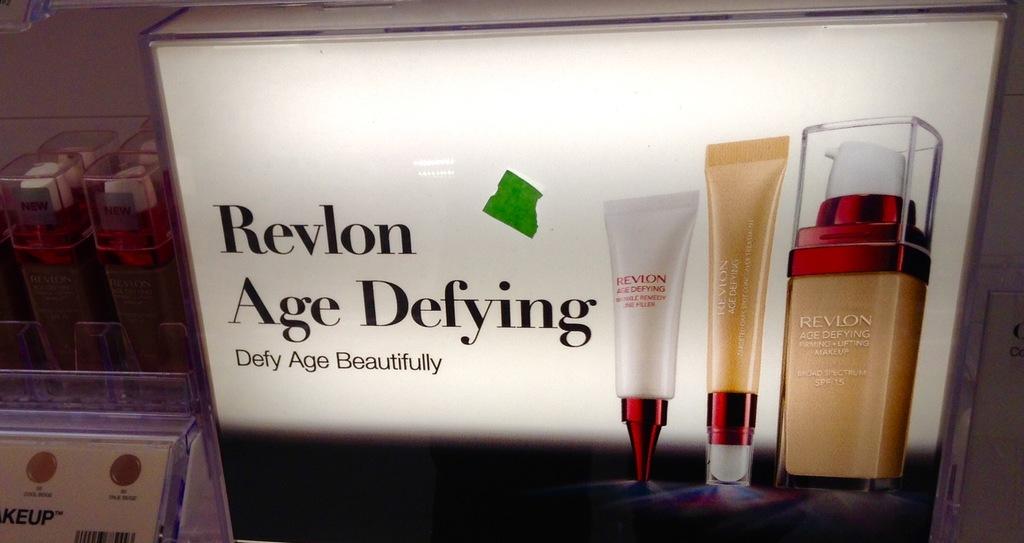What can you defy according to this ad?
Provide a short and direct response. Age. 